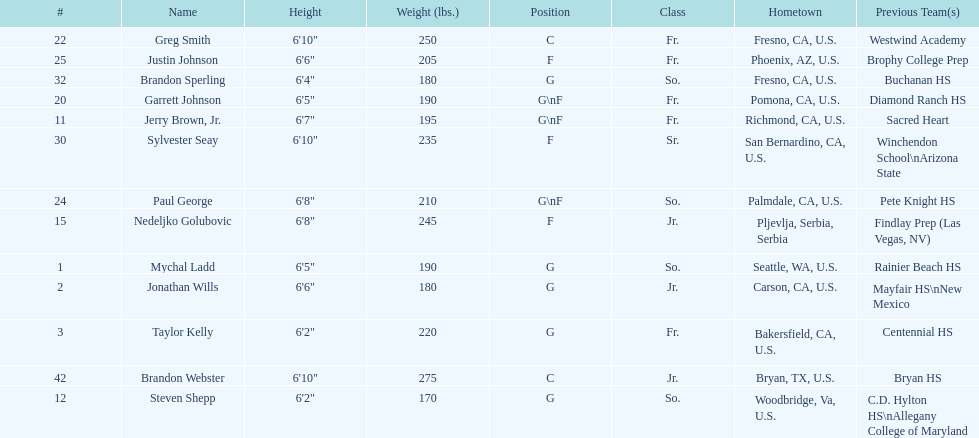How many players hometowns are outside of california? 5. 